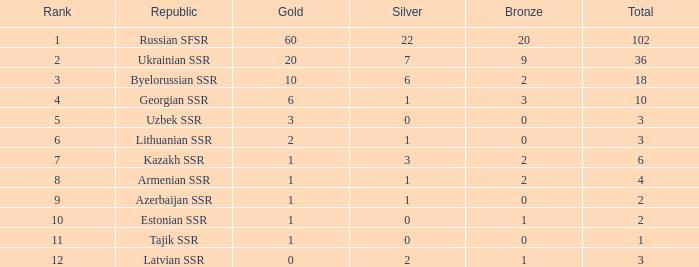What is the average total for teams with more than 1 gold, ranked over 3 and more than 3 bronze? None. 